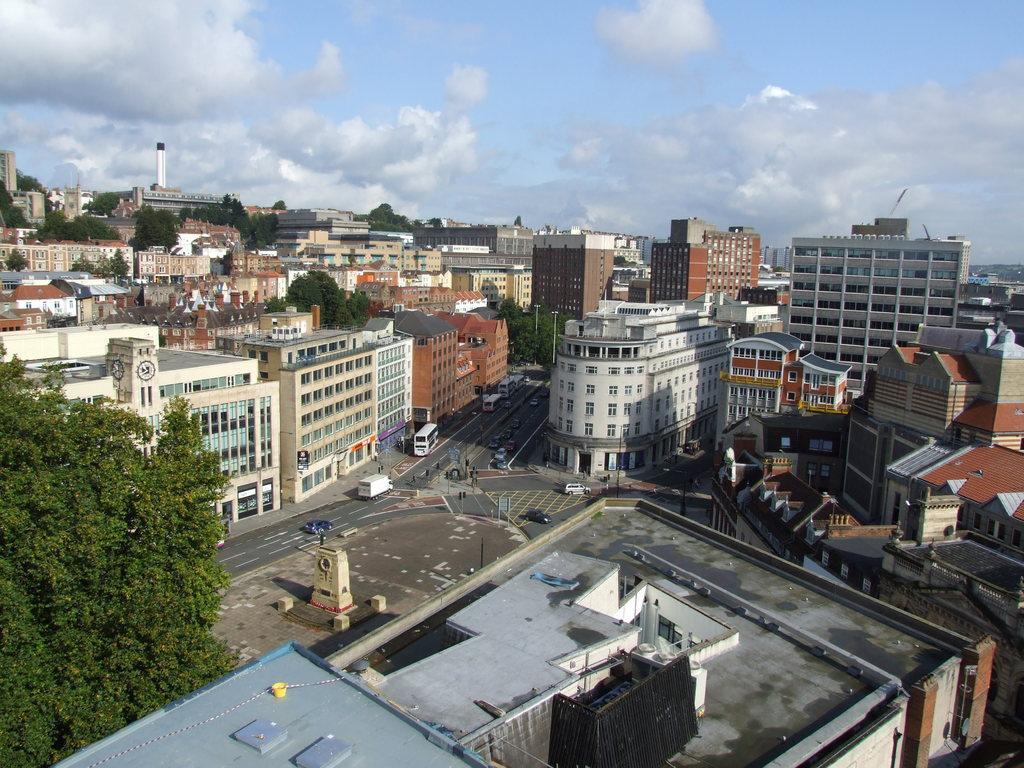In one or two sentences, can you explain what this image depicts? In this image we can see buildings, road, vehicles, poles, sky and clouds. 